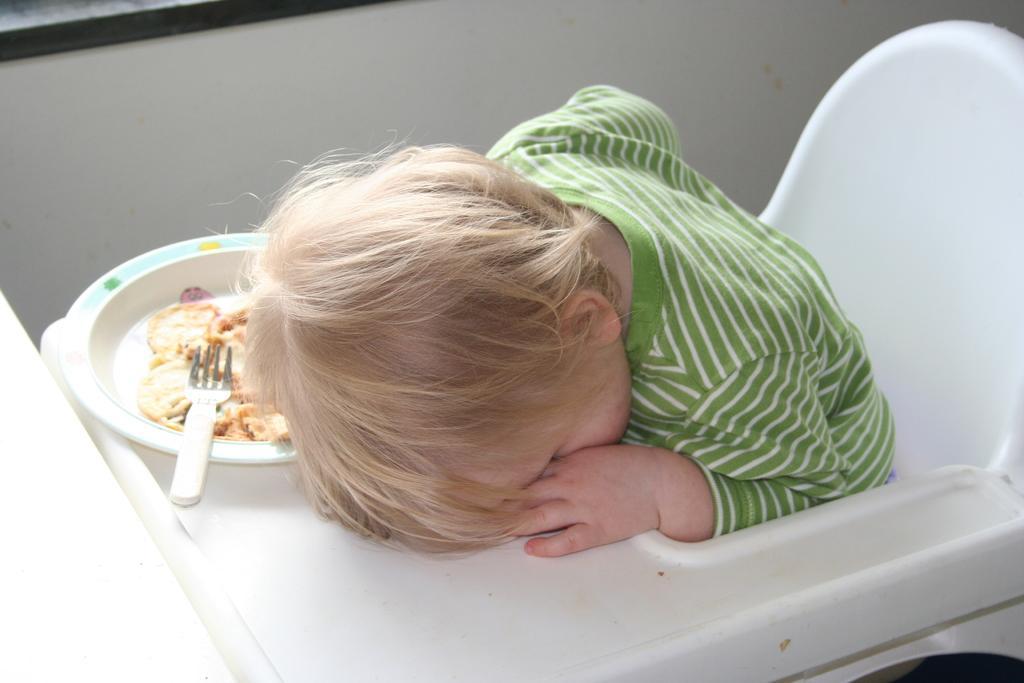Please provide a concise description of this image. In this picture I can see there is an infant sitting in the white chair and there is a plate with a spoon and food. 